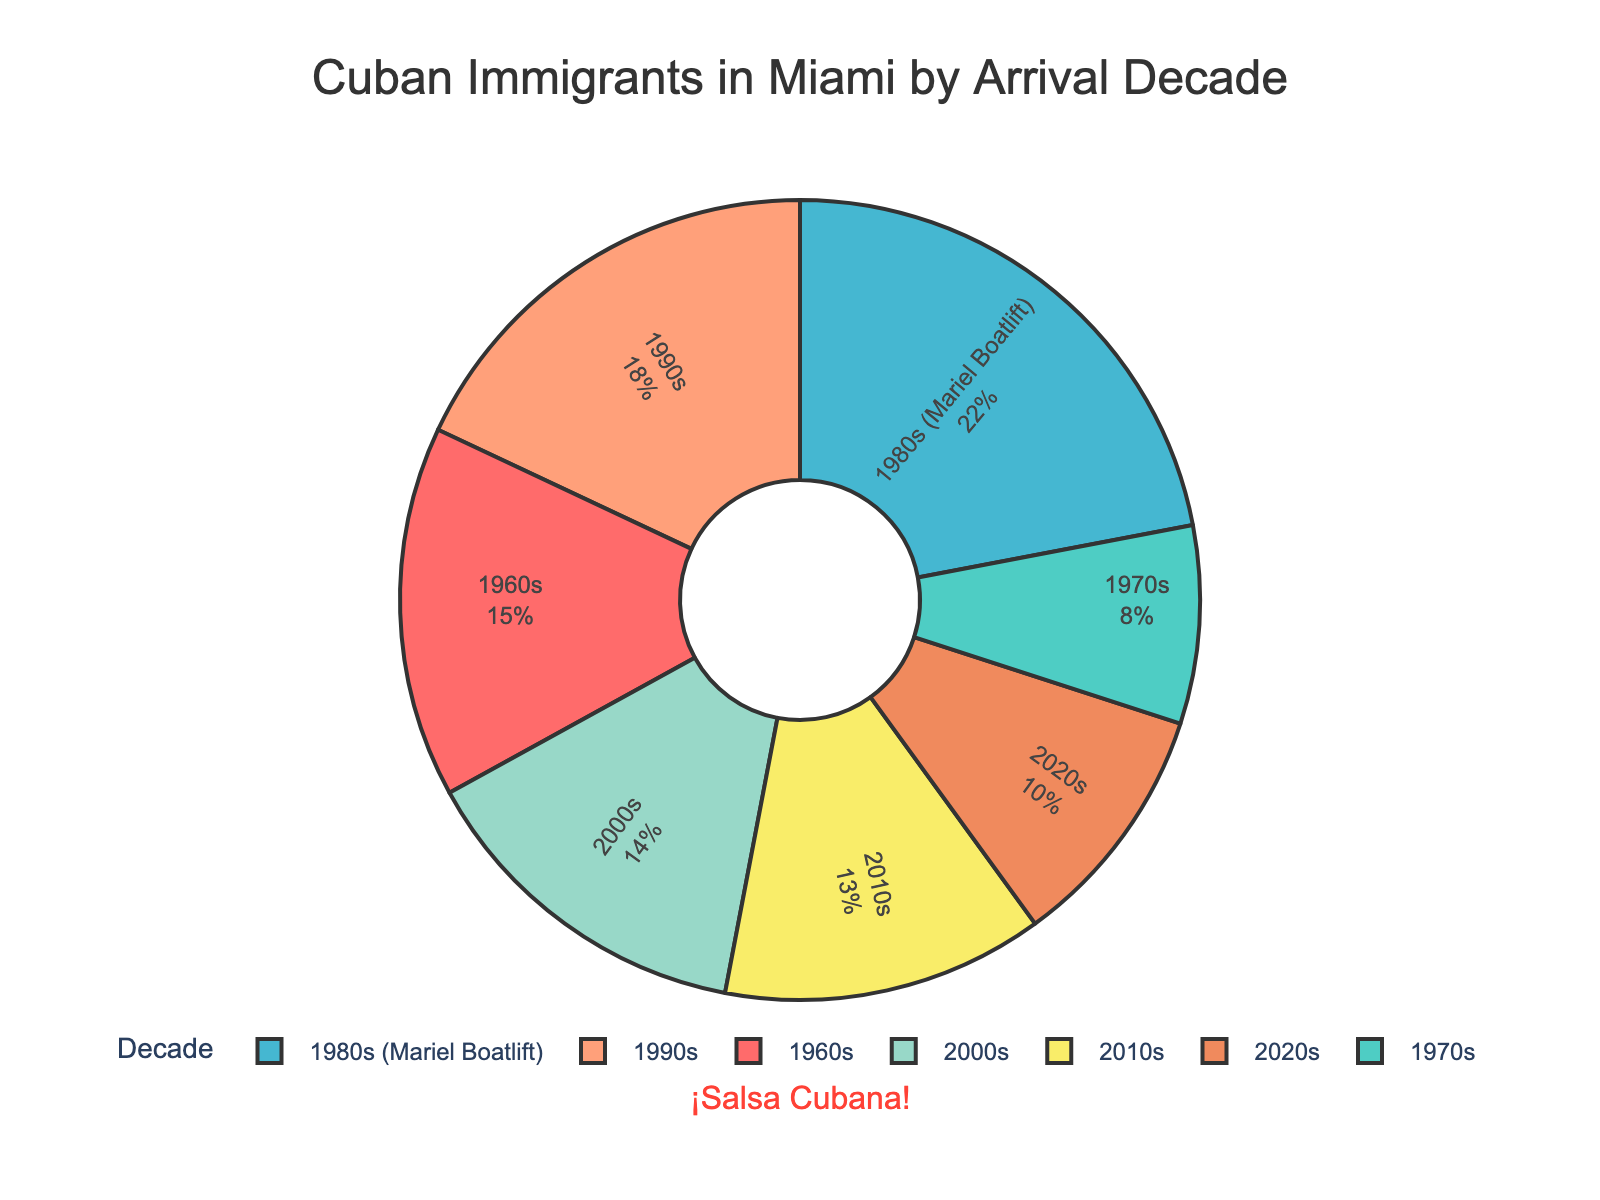Which decade had the highest percentage of Cuban immigrants arriving in Miami? The pie chart shows that the 1980s (Mariel Boatlift) section is the largest.
Answer: 1980s (Mariel Boatlift) What are the combined percentages of Cuban immigrants who arrived in the 1960s and 1970s? Add the percentages for the 1960s (15%) and the 1970s (8%). 15% + 8% = 23%.
Answer: 23% How does the percentage of Cuban immigrants arriving in the 2010s compare to those arriving in the 2000s? The chart indicates that the 2010s have 13% and the 2000s have 14%. The 2010s percentage is 1% less than the 2000s.
Answer: The 2010s have 1% less Which period has a higher percentage of Cuban immigrant arrivals: 1990s or 2020s? Compare the sections for the 1990s (18%) and the 2020s (10%). The 1990s have a higher value.
Answer: 1990s What is the sum of the percentages for the 1980s, 2000s, and 2020s? Add the percentages for the 1980s (22%), the 2000s (14%), and the 2020s (10%). 22% + 14% + 10% = 46%.
Answer: 46% Which decade has the smallest percentage of Cuban immigrants arriving in Miami? The smallest segment visible in the chart corresponds to the 1970s, which has 8%.
Answer: 1970s What is the average percentage of Cuban immigrants arriving in the decades from the 1960s to 2010s inclusive? Sum the percentages of each decade from the 1960s to the 2010s and divide by the number of decades: (15% + 8% + 22% + 18% + 14% + 13%) / 6 = 15%.
Answer: 15% How do the percentages of Cuban immigrants arriving in the 1960s and the 2020s compare? The chart shows that the 1960s have 15% and the 2020s have 10%. The 1960s percentage is 5% greater than the 2020s.
Answer: The 1960s have 5% more 